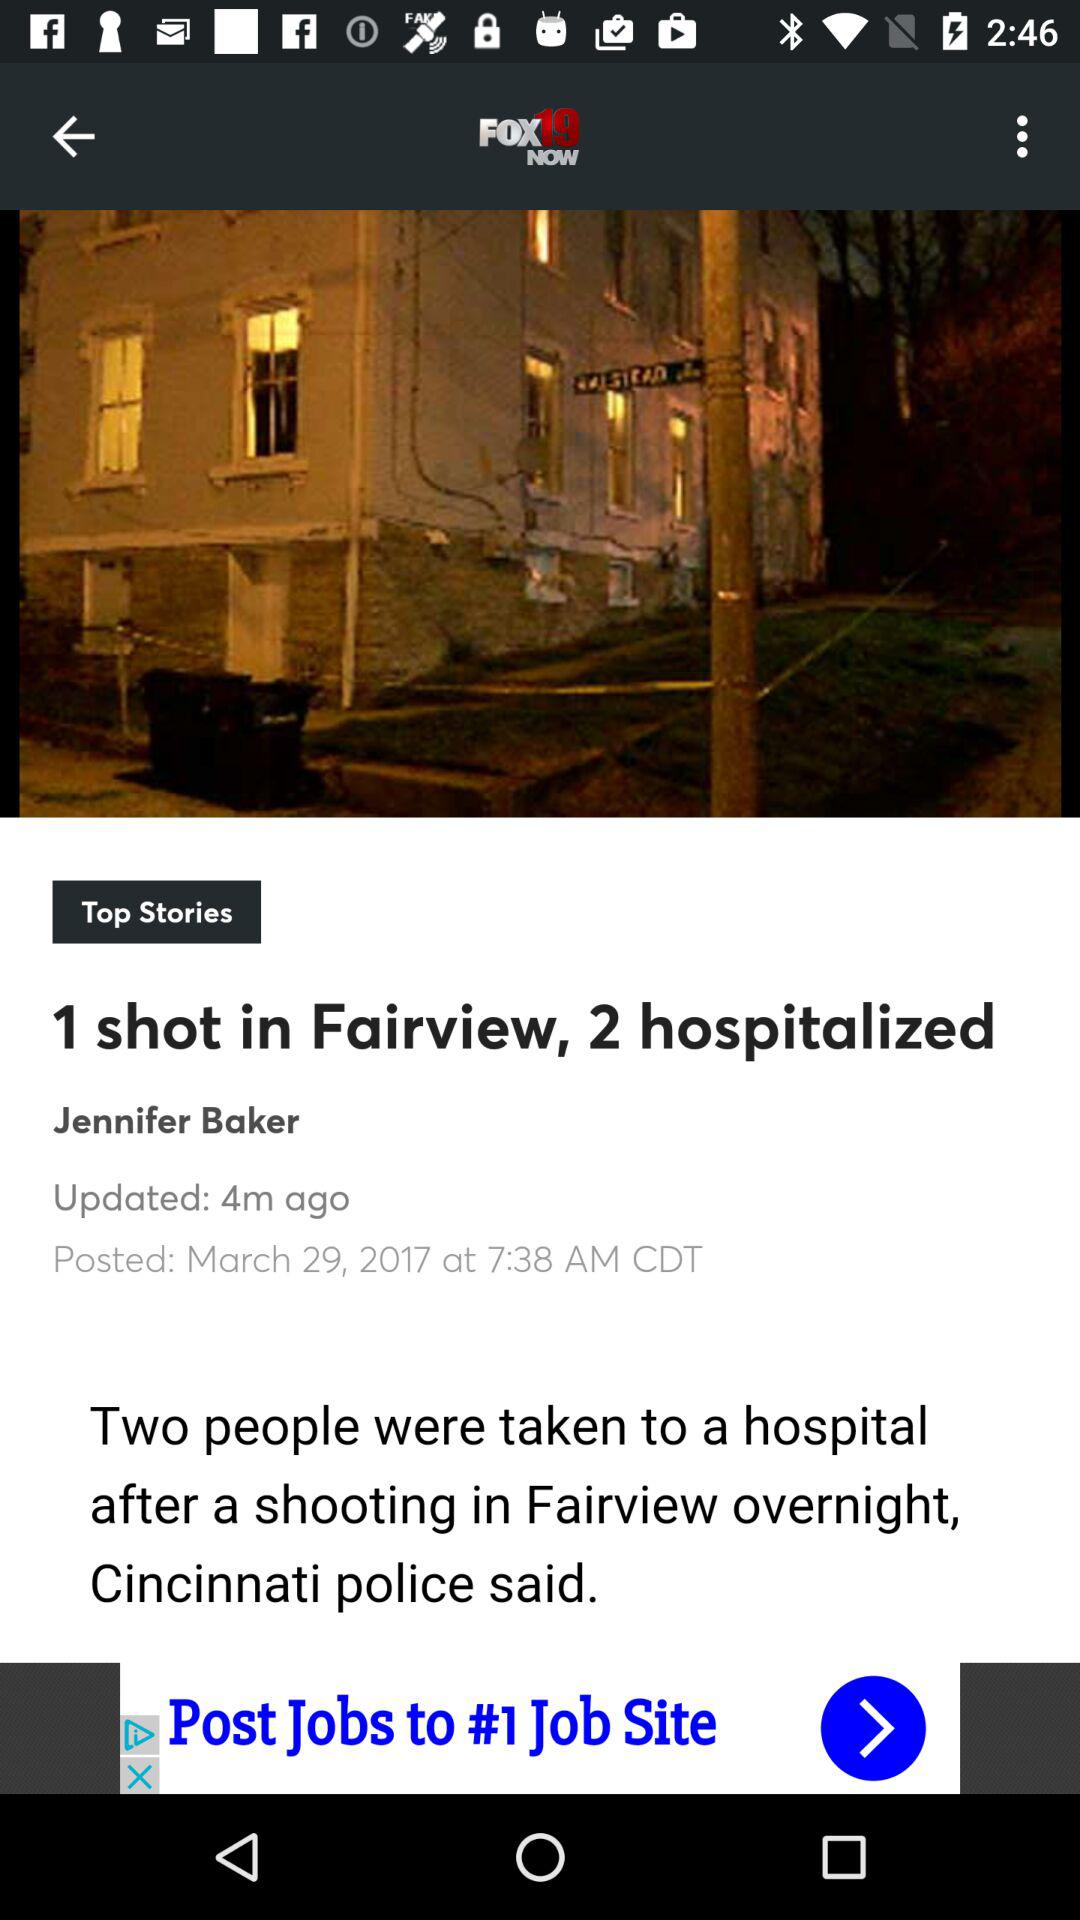What is the title of the news? The title of the news is "1 shot in Fairview, 2 hospitalized". 